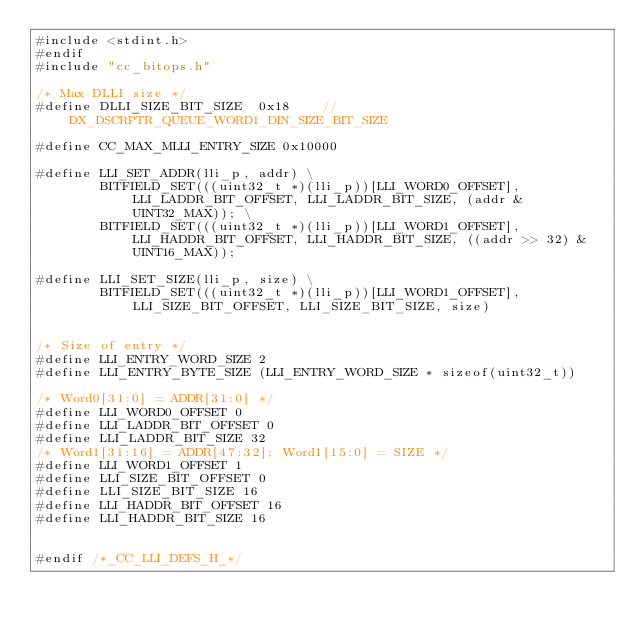<code> <loc_0><loc_0><loc_500><loc_500><_C_>#include <stdint.h>
#endif
#include "cc_bitops.h"

/* Max DLLI size */
#define DLLI_SIZE_BIT_SIZE  0x18    // DX_DSCRPTR_QUEUE_WORD1_DIN_SIZE_BIT_SIZE

#define CC_MAX_MLLI_ENTRY_SIZE 0x10000

#define LLI_SET_ADDR(lli_p, addr) \
        BITFIELD_SET(((uint32_t *)(lli_p))[LLI_WORD0_OFFSET], LLI_LADDR_BIT_OFFSET, LLI_LADDR_BIT_SIZE, (addr & UINT32_MAX)); \
        BITFIELD_SET(((uint32_t *)(lli_p))[LLI_WORD1_OFFSET], LLI_HADDR_BIT_OFFSET, LLI_HADDR_BIT_SIZE, ((addr >> 32) & UINT16_MAX));

#define LLI_SET_SIZE(lli_p, size) \
        BITFIELD_SET(((uint32_t *)(lli_p))[LLI_WORD1_OFFSET], LLI_SIZE_BIT_OFFSET, LLI_SIZE_BIT_SIZE, size)


/* Size of entry */
#define LLI_ENTRY_WORD_SIZE 2
#define LLI_ENTRY_BYTE_SIZE (LLI_ENTRY_WORD_SIZE * sizeof(uint32_t))

/* Word0[31:0] = ADDR[31:0] */
#define LLI_WORD0_OFFSET 0
#define LLI_LADDR_BIT_OFFSET 0
#define LLI_LADDR_BIT_SIZE 32
/* Word1[31:16] = ADDR[47:32]; Word1[15:0] = SIZE */
#define LLI_WORD1_OFFSET 1
#define LLI_SIZE_BIT_OFFSET 0
#define LLI_SIZE_BIT_SIZE 16
#define LLI_HADDR_BIT_OFFSET 16
#define LLI_HADDR_BIT_SIZE 16


#endif /*_CC_LLI_DEFS_H_*/
</code> 